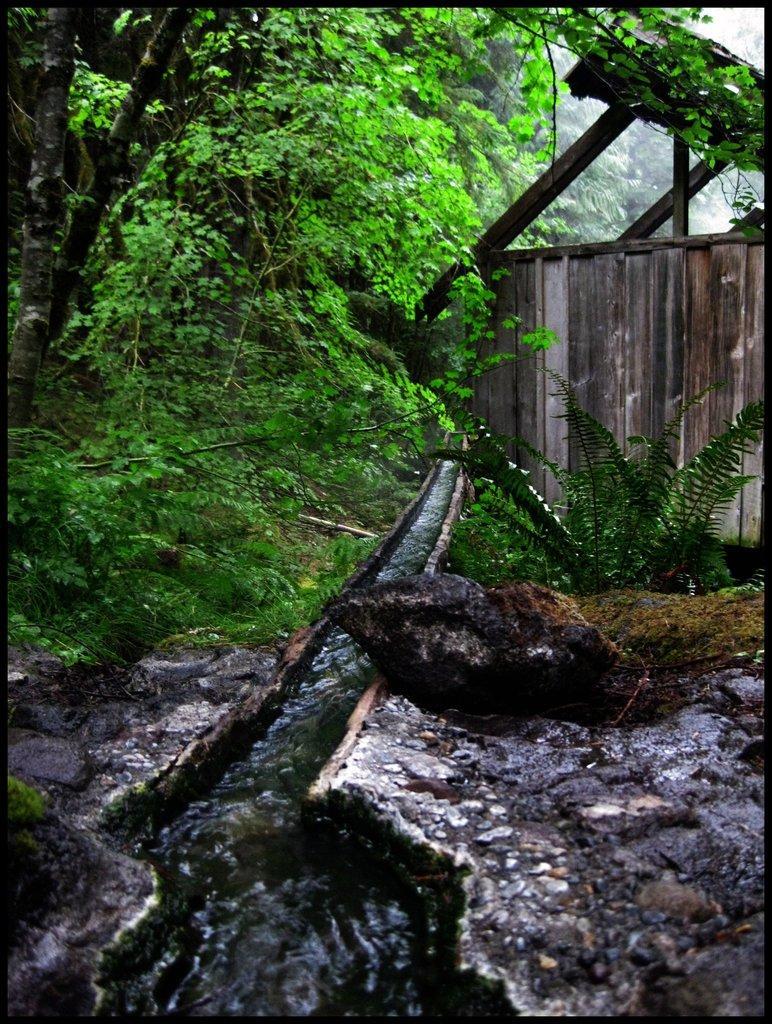In one or two sentences, can you explain what this image depicts? At the bottom of the image on the ground there are rocks. In between rocks water is flowing. On the right corner of the image there is a wooden wall with wooden poles. And in the background there are many trees. 